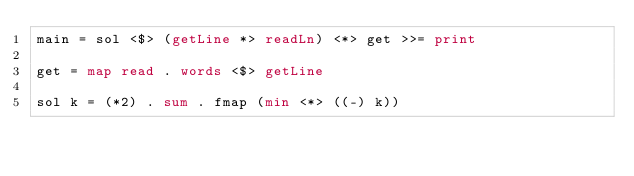Convert code to text. <code><loc_0><loc_0><loc_500><loc_500><_Haskell_>main = sol <$> (getLine *> readLn) <*> get >>= print

get = map read . words <$> getLine

sol k = (*2) . sum . fmap (min <*> ((-) k))</code> 